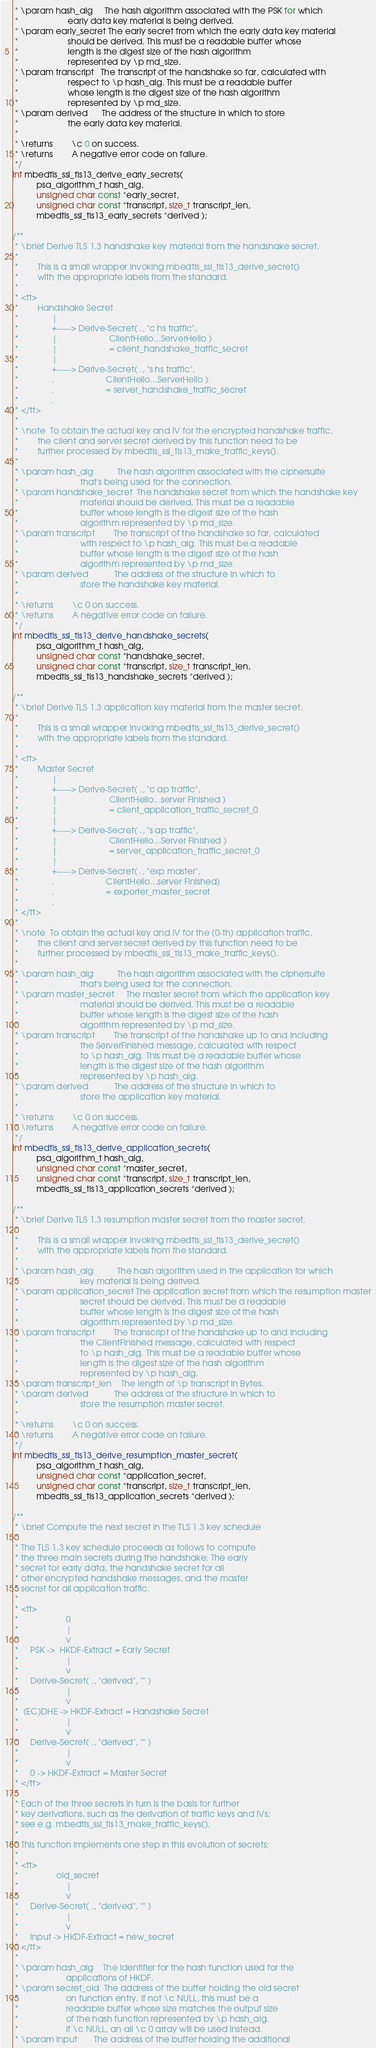<code> <loc_0><loc_0><loc_500><loc_500><_C_> * \param hash_alg     The hash algorithm associated with the PSK for which
 *                     early data key material is being derived.
 * \param early_secret The early secret from which the early data key material
 *                     should be derived. This must be a readable buffer whose
 *                     length is the digest size of the hash algorithm
 *                     represented by \p md_size.
 * \param transcript   The transcript of the handshake so far, calculated with
 *                     respect to \p hash_alg. This must be a readable buffer
 *                     whose length is the digest size of the hash algorithm
 *                     represented by \p md_size.
 * \param derived      The address of the structure in which to store
 *                     the early data key material.
 *
 * \returns        \c 0 on success.
 * \returns        A negative error code on failure.
 */
int mbedtls_ssl_tls13_derive_early_secrets(
          psa_algorithm_t hash_alg,
          unsigned char const *early_secret,
          unsigned char const *transcript, size_t transcript_len,
          mbedtls_ssl_tls13_early_secrets *derived );

/**
 * \brief Derive TLS 1.3 handshake key material from the handshake secret.
 *
 *        This is a small wrapper invoking mbedtls_ssl_tls13_derive_secret()
 *        with the appropriate labels from the standard.
 *
 * <tt>
 *        Handshake Secret
 *              |
 *              +-----> Derive-Secret( ., "c hs traffic",
 *              |                      ClientHello...ServerHello )
 *              |                      = client_handshake_traffic_secret
 *              |
 *              +-----> Derive-Secret( ., "s hs traffic",
 *              .                      ClientHello...ServerHello )
 *              .                      = server_handshake_traffic_secret
 *              .
 * </tt>
 *
 * \note  To obtain the actual key and IV for the encrypted handshake traffic,
 *        the client and server secret derived by this function need to be
 *        further processed by mbedtls_ssl_tls13_make_traffic_keys().
 *
 * \param hash_alg          The hash algorithm associated with the ciphersuite
 *                          that's being used for the connection.
 * \param handshake_secret  The handshake secret from which the handshake key
 *                          material should be derived. This must be a readable
 *                          buffer whose length is the digest size of the hash
 *                          algorithm represented by \p md_size.
 * \param transcript        The transcript of the handshake so far, calculated
 *                          with respect to \p hash_alg. This must be a readable
 *                          buffer whose length is the digest size of the hash
 *                          algorithm represented by \p md_size.
 * \param derived           The address of the structure in which to
 *                          store the handshake key material.
 *
 * \returns        \c 0 on success.
 * \returns        A negative error code on failure.
 */
int mbedtls_ssl_tls13_derive_handshake_secrets(
          psa_algorithm_t hash_alg,
          unsigned char const *handshake_secret,
          unsigned char const *transcript, size_t transcript_len,
          mbedtls_ssl_tls13_handshake_secrets *derived );

/**
 * \brief Derive TLS 1.3 application key material from the master secret.
 *
 *        This is a small wrapper invoking mbedtls_ssl_tls13_derive_secret()
 *        with the appropriate labels from the standard.
 *
 * <tt>
 *        Master Secret
 *              |
 *              +-----> Derive-Secret( ., "c ap traffic",
 *              |                      ClientHello...server Finished )
 *              |                      = client_application_traffic_secret_0
 *              |
 *              +-----> Derive-Secret( ., "s ap traffic",
 *              |                      ClientHello...Server Finished )
 *              |                      = server_application_traffic_secret_0
 *              |
 *              +-----> Derive-Secret( ., "exp master",
 *              .                      ClientHello...server Finished)
 *              .                      = exporter_master_secret
 *              .
 * </tt>
 *
 * \note  To obtain the actual key and IV for the (0-th) application traffic,
 *        the client and server secret derived by this function need to be
 *        further processed by mbedtls_ssl_tls13_make_traffic_keys().
 *
 * \param hash_alg          The hash algorithm associated with the ciphersuite
 *                          that's being used for the connection.
 * \param master_secret     The master secret from which the application key
 *                          material should be derived. This must be a readable
 *                          buffer whose length is the digest size of the hash
 *                          algorithm represented by \p md_size.
 * \param transcript        The transcript of the handshake up to and including
 *                          the ServerFinished message, calculated with respect
 *                          to \p hash_alg. This must be a readable buffer whose
 *                          length is the digest size of the hash algorithm
 *                          represented by \p hash_alg.
 * \param derived           The address of the structure in which to
 *                          store the application key material.
 *
 * \returns        \c 0 on success.
 * \returns        A negative error code on failure.
 */
int mbedtls_ssl_tls13_derive_application_secrets(
          psa_algorithm_t hash_alg,
          unsigned char const *master_secret,
          unsigned char const *transcript, size_t transcript_len,
          mbedtls_ssl_tls13_application_secrets *derived );

/**
 * \brief Derive TLS 1.3 resumption master secret from the master secret.
 *
 *        This is a small wrapper invoking mbedtls_ssl_tls13_derive_secret()
 *        with the appropriate labels from the standard.
 *
 * \param hash_alg          The hash algorithm used in the application for which
 *                          key material is being derived.
 * \param application_secret The application secret from which the resumption master
 *                          secret should be derived. This must be a readable
 *                          buffer whose length is the digest size of the hash
 *                          algorithm represented by \p md_size.
 * \param transcript        The transcript of the handshake up to and including
 *                          the ClientFinished message, calculated with respect
 *                          to \p hash_alg. This must be a readable buffer whose
 *                          length is the digest size of the hash algorithm
 *                          represented by \p hash_alg.
 * \param transcript_len    The length of \p transcript in Bytes.
 * \param derived           The address of the structure in which to
 *                          store the resumption master secret.
 *
 * \returns        \c 0 on success.
 * \returns        A negative error code on failure.
 */
int mbedtls_ssl_tls13_derive_resumption_master_secret(
          psa_algorithm_t hash_alg,
          unsigned char const *application_secret,
          unsigned char const *transcript, size_t transcript_len,
          mbedtls_ssl_tls13_application_secrets *derived );

/**
 * \brief Compute the next secret in the TLS 1.3 key schedule
 *
 * The TLS 1.3 key schedule proceeds as follows to compute
 * the three main secrets during the handshake: The early
 * secret for early data, the handshake secret for all
 * other encrypted handshake messages, and the master
 * secret for all application traffic.
 *
 * <tt>
 *                    0
 *                    |
 *                    v
 *     PSK ->  HKDF-Extract = Early Secret
 *                    |
 *                    v
 *     Derive-Secret( ., "derived", "" )
 *                    |
 *                    v
 *  (EC)DHE -> HKDF-Extract = Handshake Secret
 *                    |
 *                    v
 *     Derive-Secret( ., "derived", "" )
 *                    |
 *                    v
 *     0 -> HKDF-Extract = Master Secret
 * </tt>
 *
 * Each of the three secrets in turn is the basis for further
 * key derivations, such as the derivation of traffic keys and IVs;
 * see e.g. mbedtls_ssl_tls13_make_traffic_keys().
 *
 * This function implements one step in this evolution of secrets:
 *
 * <tt>
 *                old_secret
 *                    |
 *                    v
 *     Derive-Secret( ., "derived", "" )
 *                    |
 *                    v
 *     input -> HKDF-Extract = new_secret
 * </tt>
 *
 * \param hash_alg    The identifier for the hash function used for the
 *                    applications of HKDF.
 * \param secret_old  The address of the buffer holding the old secret
 *                    on function entry. If not \c NULL, this must be a
 *                    readable buffer whose size matches the output size
 *                    of the hash function represented by \p hash_alg.
 *                    If \c NULL, an all \c 0 array will be used instead.
 * \param input       The address of the buffer holding the additional</code> 